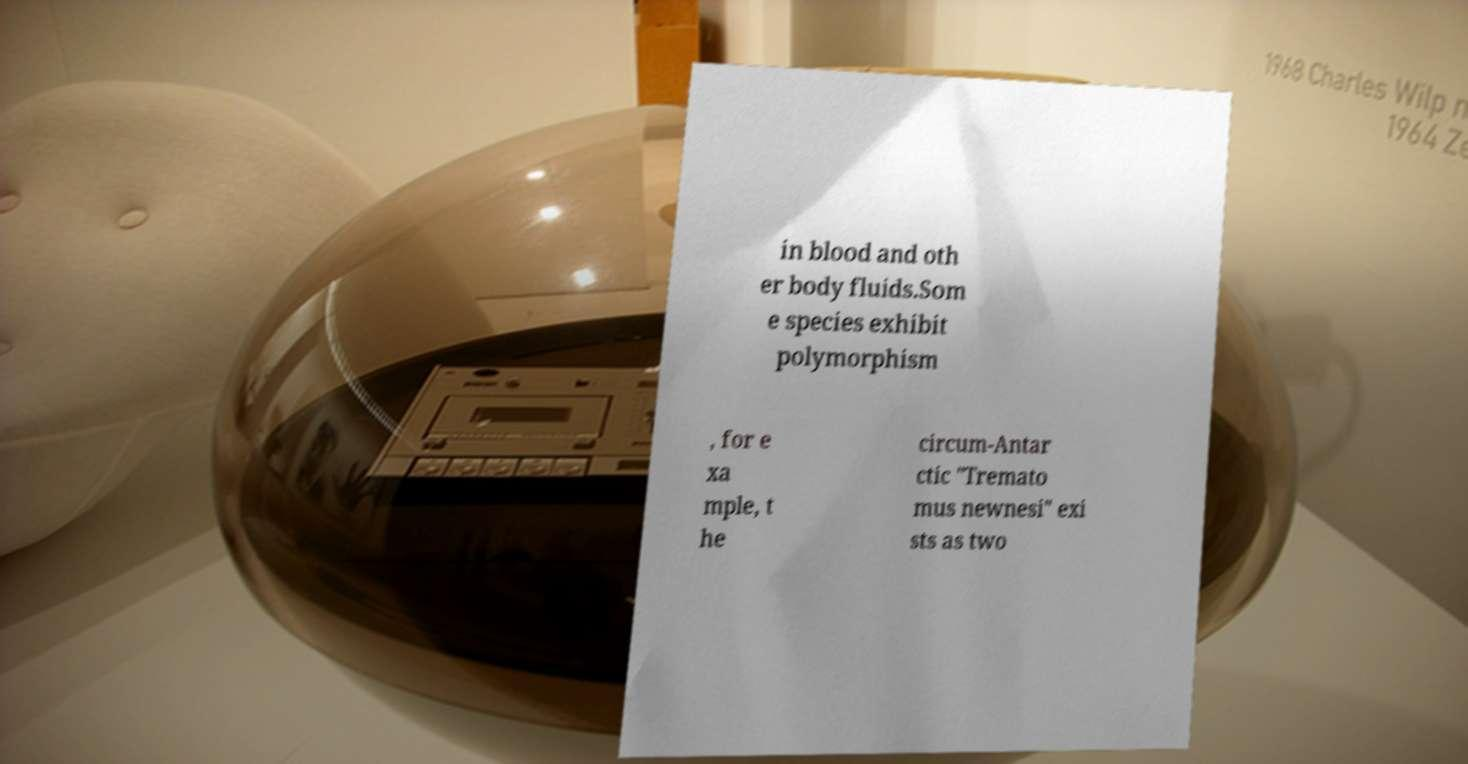Could you assist in decoding the text presented in this image and type it out clearly? in blood and oth er body fluids.Som e species exhibit polymorphism , for e xa mple, t he circum-Antar ctic "Tremato mus newnesi" exi sts as two 